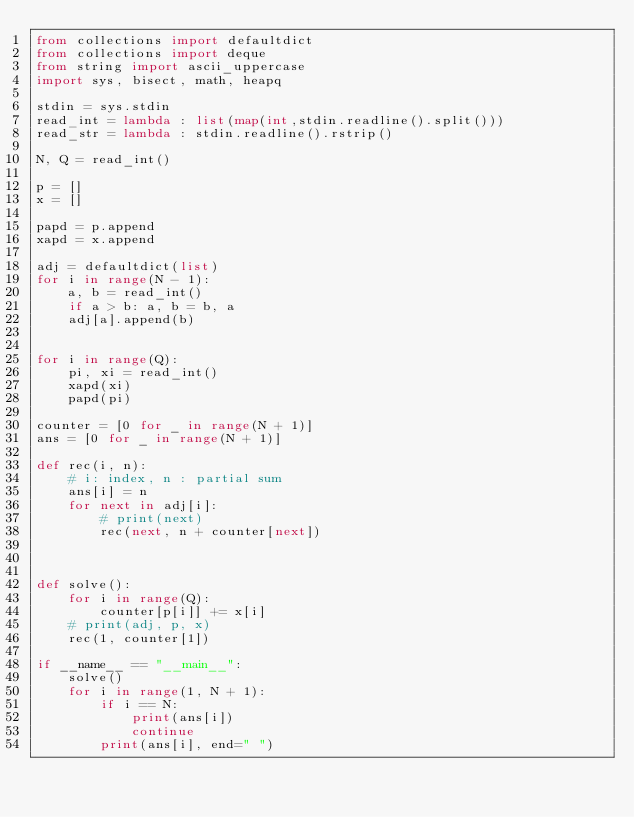<code> <loc_0><loc_0><loc_500><loc_500><_Python_>from collections import defaultdict
from collections import deque
from string import ascii_uppercase
import sys, bisect, math, heapq

stdin = sys.stdin
read_int = lambda : list(map(int,stdin.readline().split()))
read_str = lambda : stdin.readline().rstrip()

N, Q = read_int()

p = []
x = []

papd = p.append
xapd = x.append

adj = defaultdict(list)
for i in range(N - 1):
    a, b = read_int()
    if a > b: a, b = b, a
    adj[a].append(b)


for i in range(Q):
    pi, xi = read_int()
    xapd(xi)
    papd(pi)

counter = [0 for _ in range(N + 1)]
ans = [0 for _ in range(N + 1)]

def rec(i, n):
    # i: index, n : partial sum
    ans[i] = n
    for next in adj[i]:
        # print(next)
        rec(next, n + counter[next])



def solve():
    for i in range(Q):
        counter[p[i]] += x[i]
    # print(adj, p, x)
    rec(1, counter[1])

if __name__ == "__main__":
    solve()
    for i in range(1, N + 1):
        if i == N:
            print(ans[i])
            continue
        print(ans[i], end=" ")</code> 